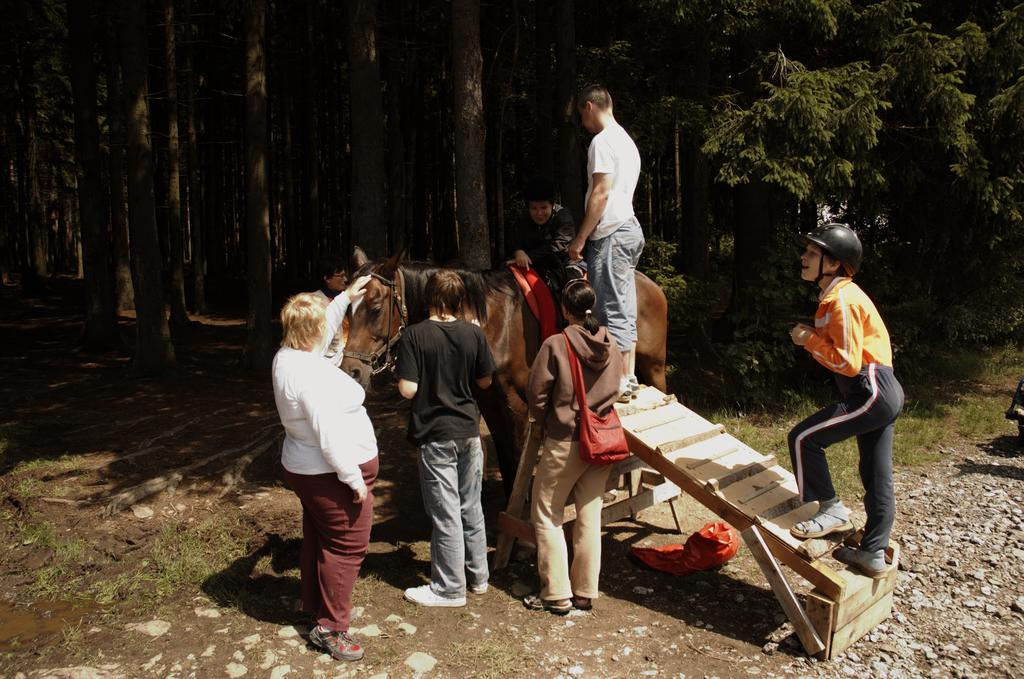What is the main subject in the center of the image? There are persons and a horse in the center of the image. What can be seen on the right side of the image? There is a person on the right side of the image, as well as stones and trees. Can you describe the trees in the image? There are trees on the right side of the image, and more trees are visible in the background. What type of pies are being used to feed the horse in the image? There are no pies present in the image, and the horse is not being fed anything. 